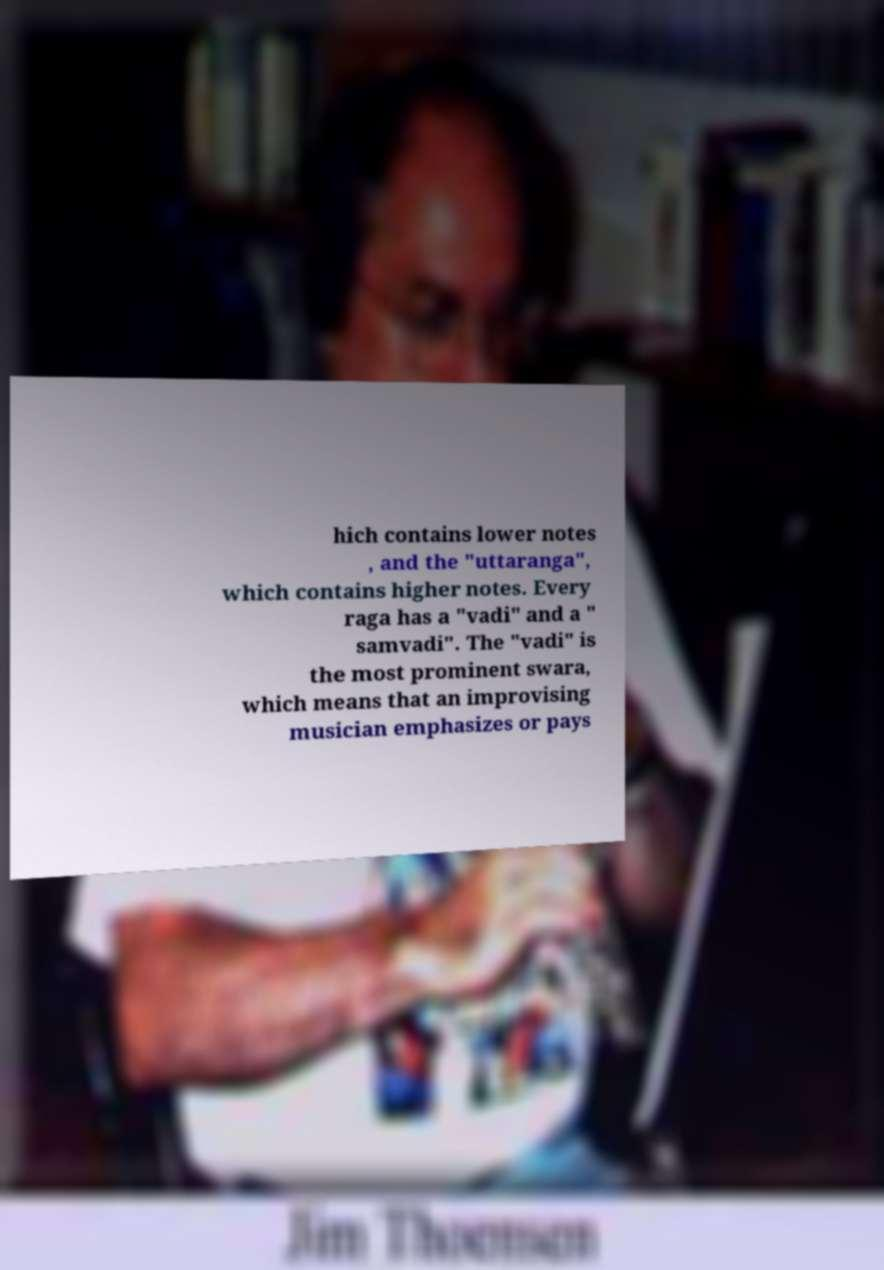Can you read and provide the text displayed in the image?This photo seems to have some interesting text. Can you extract and type it out for me? hich contains lower notes , and the "uttaranga", which contains higher notes. Every raga has a "vadi" and a " samvadi". The "vadi" is the most prominent swara, which means that an improvising musician emphasizes or pays 